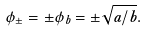Convert formula to latex. <formula><loc_0><loc_0><loc_500><loc_500>\phi _ { \pm } = \pm \phi _ { b } = \pm \sqrt { a / b } .</formula> 